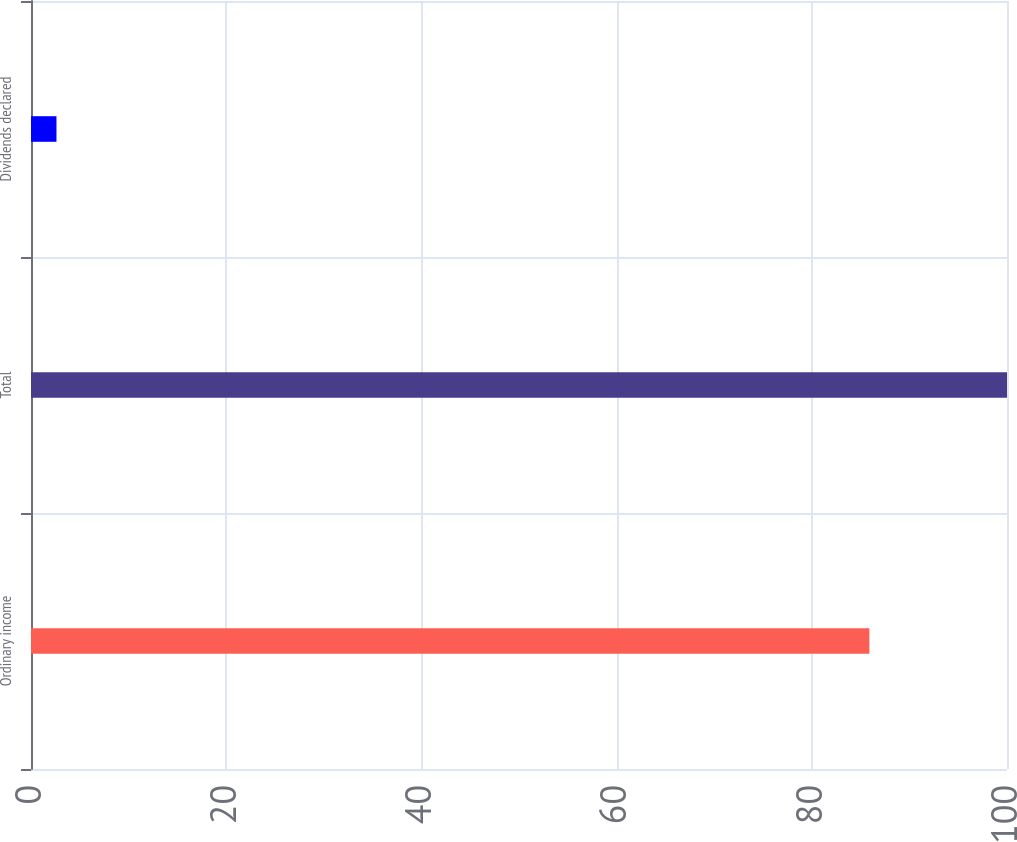Convert chart. <chart><loc_0><loc_0><loc_500><loc_500><bar_chart><fcel>Ordinary income<fcel>Total<fcel>Dividends declared<nl><fcel>85.9<fcel>100<fcel>2.61<nl></chart> 